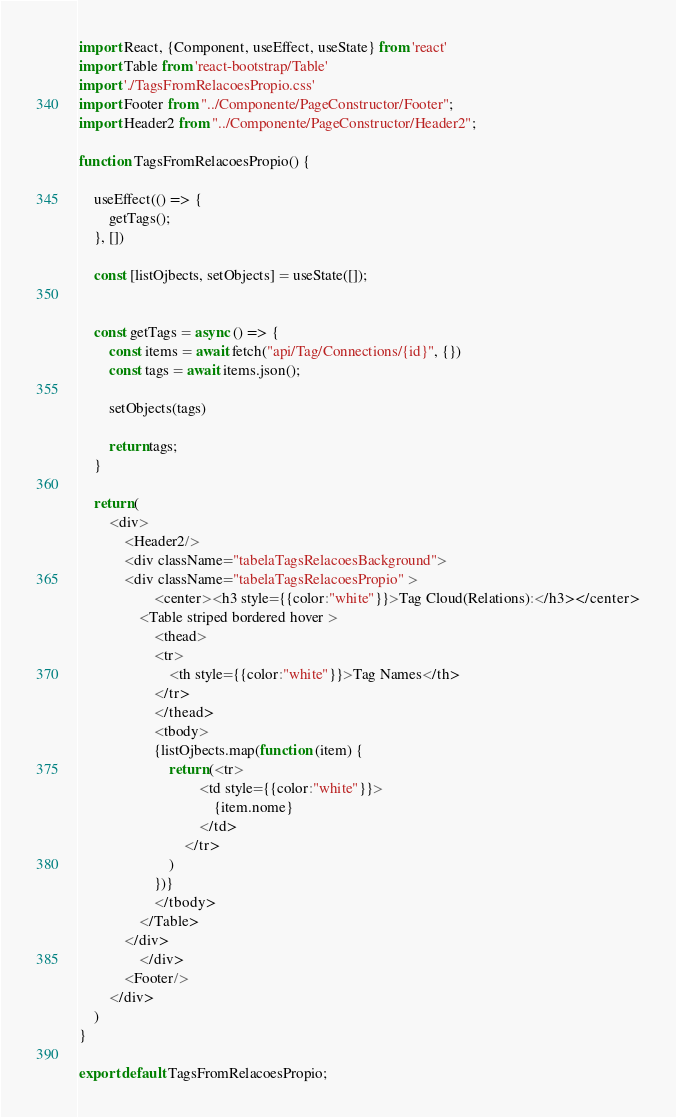Convert code to text. <code><loc_0><loc_0><loc_500><loc_500><_JavaScript_>import React, {Component, useEffect, useState} from 'react'
import Table from 'react-bootstrap/Table'
import './TagsFromRelacoesPropio.css'
import Footer from "../Componente/PageConstructor/Footer";
import Header2 from "../Componente/PageConstructor/Header2";

function TagsFromRelacoesPropio() {

    useEffect(() => {
        getTags();
    }, [])

    const [listOjbects, setObjects] = useState([]);


    const getTags = async () => {
        const items = await fetch("api/Tag/Connections/{id}", {})
        const tags = await items.json();

        setObjects(tags)

        return tags;
    }

    return (
        <div>
            <Header2/>
            <div className="tabelaTagsRelacoesBackground">
            <div className="tabelaTagsRelacoesPropio" >
                    <center><h3 style={{color:"white"}}>Tag Cloud(Relations):</h3></center>
                <Table striped bordered hover >
                    <thead>
                    <tr>
                        <th style={{color:"white"}}>Tag Names</th>
                    </tr>
                    </thead>
                    <tbody>
                    {listOjbects.map(function (item) {
                        return (<tr>
                                <td style={{color:"white"}}>
                                    {item.nome}
                                </td>
                            </tr>
                        )
                    })}
                    </tbody>
                </Table>
            </div>
                </div>
            <Footer/>
        </div>
    )
}

export default TagsFromRelacoesPropio;</code> 